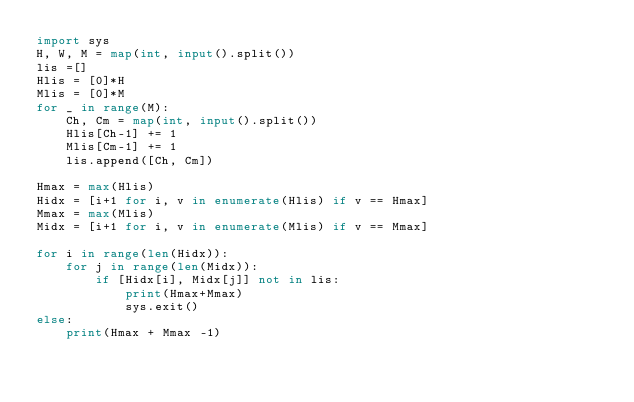Convert code to text. <code><loc_0><loc_0><loc_500><loc_500><_Python_>import sys
H, W, M = map(int, input().split())
lis =[]
Hlis = [0]*H
Mlis = [0]*M
for _ in range(M):
    Ch, Cm = map(int, input().split())
    Hlis[Ch-1] += 1
    Mlis[Cm-1] += 1
    lis.append([Ch, Cm])

Hmax = max(Hlis)
Hidx = [i+1 for i, v in enumerate(Hlis) if v == Hmax]
Mmax = max(Mlis)
Midx = [i+1 for i, v in enumerate(Mlis) if v == Mmax]

for i in range(len(Hidx)):
    for j in range(len(Midx)):
        if [Hidx[i], Midx[j]] not in lis:
            print(Hmax+Mmax)
            sys.exit()
else:
    print(Hmax + Mmax -1)</code> 